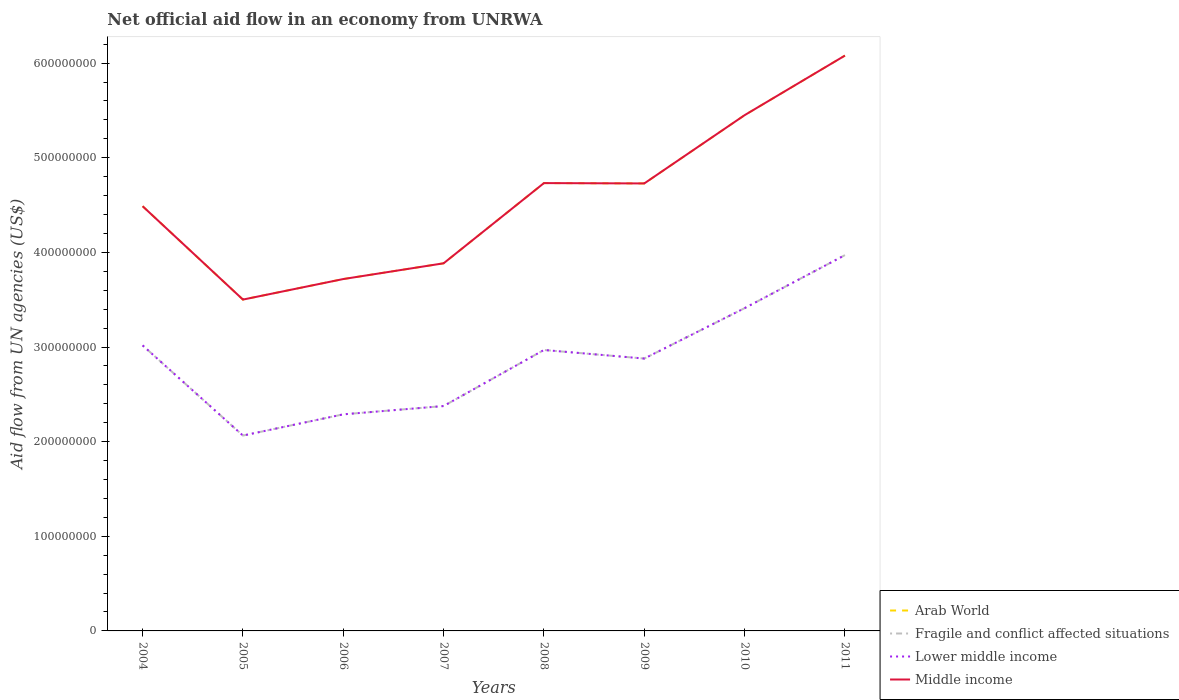How many different coloured lines are there?
Give a very brief answer. 4. Across all years, what is the maximum net official aid flow in Fragile and conflict affected situations?
Make the answer very short. 2.06e+08. In which year was the net official aid flow in Lower middle income maximum?
Your answer should be very brief. 2005. What is the total net official aid flow in Fragile and conflict affected situations in the graph?
Keep it short and to the point. -1.09e+08. What is the difference between the highest and the second highest net official aid flow in Fragile and conflict affected situations?
Provide a succinct answer. 1.91e+08. Is the net official aid flow in Fragile and conflict affected situations strictly greater than the net official aid flow in Arab World over the years?
Keep it short and to the point. Yes. How many years are there in the graph?
Make the answer very short. 8. Are the values on the major ticks of Y-axis written in scientific E-notation?
Your response must be concise. No. Does the graph contain any zero values?
Offer a terse response. No. Does the graph contain grids?
Provide a succinct answer. No. How are the legend labels stacked?
Give a very brief answer. Vertical. What is the title of the graph?
Give a very brief answer. Net official aid flow in an economy from UNRWA. What is the label or title of the Y-axis?
Give a very brief answer. Aid flow from UN agencies (US$). What is the Aid flow from UN agencies (US$) in Arab World in 2004?
Offer a terse response. 4.49e+08. What is the Aid flow from UN agencies (US$) of Fragile and conflict affected situations in 2004?
Offer a terse response. 3.02e+08. What is the Aid flow from UN agencies (US$) of Lower middle income in 2004?
Offer a terse response. 3.02e+08. What is the Aid flow from UN agencies (US$) in Middle income in 2004?
Ensure brevity in your answer.  4.49e+08. What is the Aid flow from UN agencies (US$) of Arab World in 2005?
Your answer should be very brief. 3.50e+08. What is the Aid flow from UN agencies (US$) of Fragile and conflict affected situations in 2005?
Provide a short and direct response. 2.06e+08. What is the Aid flow from UN agencies (US$) of Lower middle income in 2005?
Your response must be concise. 2.06e+08. What is the Aid flow from UN agencies (US$) of Middle income in 2005?
Your answer should be very brief. 3.50e+08. What is the Aid flow from UN agencies (US$) of Arab World in 2006?
Offer a very short reply. 3.72e+08. What is the Aid flow from UN agencies (US$) of Fragile and conflict affected situations in 2006?
Offer a very short reply. 2.29e+08. What is the Aid flow from UN agencies (US$) in Lower middle income in 2006?
Provide a short and direct response. 2.29e+08. What is the Aid flow from UN agencies (US$) of Middle income in 2006?
Your answer should be compact. 3.72e+08. What is the Aid flow from UN agencies (US$) of Arab World in 2007?
Keep it short and to the point. 3.88e+08. What is the Aid flow from UN agencies (US$) in Fragile and conflict affected situations in 2007?
Ensure brevity in your answer.  2.38e+08. What is the Aid flow from UN agencies (US$) of Lower middle income in 2007?
Your answer should be very brief. 2.38e+08. What is the Aid flow from UN agencies (US$) of Middle income in 2007?
Your answer should be very brief. 3.88e+08. What is the Aid flow from UN agencies (US$) of Arab World in 2008?
Your answer should be very brief. 4.73e+08. What is the Aid flow from UN agencies (US$) of Fragile and conflict affected situations in 2008?
Your answer should be compact. 2.97e+08. What is the Aid flow from UN agencies (US$) in Lower middle income in 2008?
Provide a short and direct response. 2.97e+08. What is the Aid flow from UN agencies (US$) in Middle income in 2008?
Your answer should be compact. 4.73e+08. What is the Aid flow from UN agencies (US$) in Arab World in 2009?
Your response must be concise. 4.73e+08. What is the Aid flow from UN agencies (US$) of Fragile and conflict affected situations in 2009?
Give a very brief answer. 2.88e+08. What is the Aid flow from UN agencies (US$) in Lower middle income in 2009?
Ensure brevity in your answer.  2.88e+08. What is the Aid flow from UN agencies (US$) in Middle income in 2009?
Your answer should be compact. 4.73e+08. What is the Aid flow from UN agencies (US$) in Arab World in 2010?
Provide a succinct answer. 5.45e+08. What is the Aid flow from UN agencies (US$) in Fragile and conflict affected situations in 2010?
Keep it short and to the point. 3.41e+08. What is the Aid flow from UN agencies (US$) in Lower middle income in 2010?
Make the answer very short. 3.41e+08. What is the Aid flow from UN agencies (US$) in Middle income in 2010?
Ensure brevity in your answer.  5.45e+08. What is the Aid flow from UN agencies (US$) of Arab World in 2011?
Provide a succinct answer. 6.08e+08. What is the Aid flow from UN agencies (US$) in Fragile and conflict affected situations in 2011?
Offer a terse response. 3.97e+08. What is the Aid flow from UN agencies (US$) in Lower middle income in 2011?
Ensure brevity in your answer.  3.97e+08. What is the Aid flow from UN agencies (US$) in Middle income in 2011?
Provide a short and direct response. 6.08e+08. Across all years, what is the maximum Aid flow from UN agencies (US$) of Arab World?
Keep it short and to the point. 6.08e+08. Across all years, what is the maximum Aid flow from UN agencies (US$) of Fragile and conflict affected situations?
Your answer should be very brief. 3.97e+08. Across all years, what is the maximum Aid flow from UN agencies (US$) of Lower middle income?
Give a very brief answer. 3.97e+08. Across all years, what is the maximum Aid flow from UN agencies (US$) of Middle income?
Your answer should be compact. 6.08e+08. Across all years, what is the minimum Aid flow from UN agencies (US$) of Arab World?
Provide a short and direct response. 3.50e+08. Across all years, what is the minimum Aid flow from UN agencies (US$) in Fragile and conflict affected situations?
Your response must be concise. 2.06e+08. Across all years, what is the minimum Aid flow from UN agencies (US$) in Lower middle income?
Your answer should be very brief. 2.06e+08. Across all years, what is the minimum Aid flow from UN agencies (US$) of Middle income?
Your response must be concise. 3.50e+08. What is the total Aid flow from UN agencies (US$) in Arab World in the graph?
Provide a succinct answer. 3.66e+09. What is the total Aid flow from UN agencies (US$) of Fragile and conflict affected situations in the graph?
Your answer should be compact. 2.30e+09. What is the total Aid flow from UN agencies (US$) in Lower middle income in the graph?
Ensure brevity in your answer.  2.30e+09. What is the total Aid flow from UN agencies (US$) in Middle income in the graph?
Keep it short and to the point. 3.66e+09. What is the difference between the Aid flow from UN agencies (US$) of Arab World in 2004 and that in 2005?
Make the answer very short. 9.87e+07. What is the difference between the Aid flow from UN agencies (US$) in Fragile and conflict affected situations in 2004 and that in 2005?
Keep it short and to the point. 9.53e+07. What is the difference between the Aid flow from UN agencies (US$) of Lower middle income in 2004 and that in 2005?
Your answer should be very brief. 9.53e+07. What is the difference between the Aid flow from UN agencies (US$) of Middle income in 2004 and that in 2005?
Keep it short and to the point. 9.87e+07. What is the difference between the Aid flow from UN agencies (US$) in Arab World in 2004 and that in 2006?
Offer a terse response. 7.70e+07. What is the difference between the Aid flow from UN agencies (US$) of Fragile and conflict affected situations in 2004 and that in 2006?
Provide a short and direct response. 7.29e+07. What is the difference between the Aid flow from UN agencies (US$) of Lower middle income in 2004 and that in 2006?
Your answer should be compact. 7.29e+07. What is the difference between the Aid flow from UN agencies (US$) in Middle income in 2004 and that in 2006?
Ensure brevity in your answer.  7.70e+07. What is the difference between the Aid flow from UN agencies (US$) in Arab World in 2004 and that in 2007?
Keep it short and to the point. 6.03e+07. What is the difference between the Aid flow from UN agencies (US$) in Fragile and conflict affected situations in 2004 and that in 2007?
Provide a short and direct response. 6.41e+07. What is the difference between the Aid flow from UN agencies (US$) in Lower middle income in 2004 and that in 2007?
Offer a very short reply. 6.41e+07. What is the difference between the Aid flow from UN agencies (US$) of Middle income in 2004 and that in 2007?
Your answer should be very brief. 6.03e+07. What is the difference between the Aid flow from UN agencies (US$) of Arab World in 2004 and that in 2008?
Give a very brief answer. -2.44e+07. What is the difference between the Aid flow from UN agencies (US$) of Fragile and conflict affected situations in 2004 and that in 2008?
Provide a succinct answer. 4.86e+06. What is the difference between the Aid flow from UN agencies (US$) of Lower middle income in 2004 and that in 2008?
Offer a terse response. 4.86e+06. What is the difference between the Aid flow from UN agencies (US$) of Middle income in 2004 and that in 2008?
Provide a short and direct response. -2.44e+07. What is the difference between the Aid flow from UN agencies (US$) in Arab World in 2004 and that in 2009?
Make the answer very short. -2.40e+07. What is the difference between the Aid flow from UN agencies (US$) of Fragile and conflict affected situations in 2004 and that in 2009?
Offer a terse response. 1.39e+07. What is the difference between the Aid flow from UN agencies (US$) in Lower middle income in 2004 and that in 2009?
Your response must be concise. 1.39e+07. What is the difference between the Aid flow from UN agencies (US$) of Middle income in 2004 and that in 2009?
Ensure brevity in your answer.  -2.40e+07. What is the difference between the Aid flow from UN agencies (US$) of Arab World in 2004 and that in 2010?
Offer a very short reply. -9.62e+07. What is the difference between the Aid flow from UN agencies (US$) in Fragile and conflict affected situations in 2004 and that in 2010?
Keep it short and to the point. -3.94e+07. What is the difference between the Aid flow from UN agencies (US$) in Lower middle income in 2004 and that in 2010?
Your answer should be compact. -3.94e+07. What is the difference between the Aid flow from UN agencies (US$) of Middle income in 2004 and that in 2010?
Make the answer very short. -9.62e+07. What is the difference between the Aid flow from UN agencies (US$) in Arab World in 2004 and that in 2011?
Keep it short and to the point. -1.59e+08. What is the difference between the Aid flow from UN agencies (US$) of Fragile and conflict affected situations in 2004 and that in 2011?
Keep it short and to the point. -9.54e+07. What is the difference between the Aid flow from UN agencies (US$) in Lower middle income in 2004 and that in 2011?
Offer a terse response. -9.54e+07. What is the difference between the Aid flow from UN agencies (US$) in Middle income in 2004 and that in 2011?
Ensure brevity in your answer.  -1.59e+08. What is the difference between the Aid flow from UN agencies (US$) of Arab World in 2005 and that in 2006?
Provide a short and direct response. -2.17e+07. What is the difference between the Aid flow from UN agencies (US$) of Fragile and conflict affected situations in 2005 and that in 2006?
Provide a short and direct response. -2.24e+07. What is the difference between the Aid flow from UN agencies (US$) of Lower middle income in 2005 and that in 2006?
Ensure brevity in your answer.  -2.24e+07. What is the difference between the Aid flow from UN agencies (US$) of Middle income in 2005 and that in 2006?
Your answer should be very brief. -2.17e+07. What is the difference between the Aid flow from UN agencies (US$) of Arab World in 2005 and that in 2007?
Ensure brevity in your answer.  -3.83e+07. What is the difference between the Aid flow from UN agencies (US$) in Fragile and conflict affected situations in 2005 and that in 2007?
Your answer should be compact. -3.12e+07. What is the difference between the Aid flow from UN agencies (US$) in Lower middle income in 2005 and that in 2007?
Your answer should be very brief. -3.12e+07. What is the difference between the Aid flow from UN agencies (US$) in Middle income in 2005 and that in 2007?
Your answer should be very brief. -3.83e+07. What is the difference between the Aid flow from UN agencies (US$) in Arab World in 2005 and that in 2008?
Give a very brief answer. -1.23e+08. What is the difference between the Aid flow from UN agencies (US$) in Fragile and conflict affected situations in 2005 and that in 2008?
Your answer should be compact. -9.04e+07. What is the difference between the Aid flow from UN agencies (US$) of Lower middle income in 2005 and that in 2008?
Offer a terse response. -9.04e+07. What is the difference between the Aid flow from UN agencies (US$) of Middle income in 2005 and that in 2008?
Provide a succinct answer. -1.23e+08. What is the difference between the Aid flow from UN agencies (US$) of Arab World in 2005 and that in 2009?
Your answer should be compact. -1.23e+08. What is the difference between the Aid flow from UN agencies (US$) of Fragile and conflict affected situations in 2005 and that in 2009?
Give a very brief answer. -8.14e+07. What is the difference between the Aid flow from UN agencies (US$) of Lower middle income in 2005 and that in 2009?
Offer a very short reply. -8.14e+07. What is the difference between the Aid flow from UN agencies (US$) of Middle income in 2005 and that in 2009?
Offer a very short reply. -1.23e+08. What is the difference between the Aid flow from UN agencies (US$) of Arab World in 2005 and that in 2010?
Keep it short and to the point. -1.95e+08. What is the difference between the Aid flow from UN agencies (US$) of Fragile and conflict affected situations in 2005 and that in 2010?
Provide a succinct answer. -1.35e+08. What is the difference between the Aid flow from UN agencies (US$) in Lower middle income in 2005 and that in 2010?
Your response must be concise. -1.35e+08. What is the difference between the Aid flow from UN agencies (US$) of Middle income in 2005 and that in 2010?
Your response must be concise. -1.95e+08. What is the difference between the Aid flow from UN agencies (US$) of Arab World in 2005 and that in 2011?
Offer a terse response. -2.58e+08. What is the difference between the Aid flow from UN agencies (US$) in Fragile and conflict affected situations in 2005 and that in 2011?
Offer a very short reply. -1.91e+08. What is the difference between the Aid flow from UN agencies (US$) in Lower middle income in 2005 and that in 2011?
Ensure brevity in your answer.  -1.91e+08. What is the difference between the Aid flow from UN agencies (US$) of Middle income in 2005 and that in 2011?
Your answer should be compact. -2.58e+08. What is the difference between the Aid flow from UN agencies (US$) in Arab World in 2006 and that in 2007?
Offer a terse response. -1.66e+07. What is the difference between the Aid flow from UN agencies (US$) in Fragile and conflict affected situations in 2006 and that in 2007?
Offer a terse response. -8.77e+06. What is the difference between the Aid flow from UN agencies (US$) in Lower middle income in 2006 and that in 2007?
Offer a terse response. -8.77e+06. What is the difference between the Aid flow from UN agencies (US$) in Middle income in 2006 and that in 2007?
Offer a terse response. -1.66e+07. What is the difference between the Aid flow from UN agencies (US$) of Arab World in 2006 and that in 2008?
Provide a succinct answer. -1.01e+08. What is the difference between the Aid flow from UN agencies (US$) in Fragile and conflict affected situations in 2006 and that in 2008?
Your response must be concise. -6.80e+07. What is the difference between the Aid flow from UN agencies (US$) of Lower middle income in 2006 and that in 2008?
Make the answer very short. -6.80e+07. What is the difference between the Aid flow from UN agencies (US$) in Middle income in 2006 and that in 2008?
Make the answer very short. -1.01e+08. What is the difference between the Aid flow from UN agencies (US$) in Arab World in 2006 and that in 2009?
Give a very brief answer. -1.01e+08. What is the difference between the Aid flow from UN agencies (US$) in Fragile and conflict affected situations in 2006 and that in 2009?
Provide a succinct answer. -5.90e+07. What is the difference between the Aid flow from UN agencies (US$) of Lower middle income in 2006 and that in 2009?
Your answer should be very brief. -5.90e+07. What is the difference between the Aid flow from UN agencies (US$) of Middle income in 2006 and that in 2009?
Give a very brief answer. -1.01e+08. What is the difference between the Aid flow from UN agencies (US$) in Arab World in 2006 and that in 2010?
Your answer should be very brief. -1.73e+08. What is the difference between the Aid flow from UN agencies (US$) of Fragile and conflict affected situations in 2006 and that in 2010?
Your answer should be very brief. -1.12e+08. What is the difference between the Aid flow from UN agencies (US$) in Lower middle income in 2006 and that in 2010?
Provide a succinct answer. -1.12e+08. What is the difference between the Aid flow from UN agencies (US$) of Middle income in 2006 and that in 2010?
Keep it short and to the point. -1.73e+08. What is the difference between the Aid flow from UN agencies (US$) of Arab World in 2006 and that in 2011?
Offer a very short reply. -2.36e+08. What is the difference between the Aid flow from UN agencies (US$) of Fragile and conflict affected situations in 2006 and that in 2011?
Keep it short and to the point. -1.68e+08. What is the difference between the Aid flow from UN agencies (US$) of Lower middle income in 2006 and that in 2011?
Your answer should be compact. -1.68e+08. What is the difference between the Aid flow from UN agencies (US$) of Middle income in 2006 and that in 2011?
Offer a very short reply. -2.36e+08. What is the difference between the Aid flow from UN agencies (US$) in Arab World in 2007 and that in 2008?
Provide a succinct answer. -8.48e+07. What is the difference between the Aid flow from UN agencies (US$) of Fragile and conflict affected situations in 2007 and that in 2008?
Provide a short and direct response. -5.92e+07. What is the difference between the Aid flow from UN agencies (US$) of Lower middle income in 2007 and that in 2008?
Provide a succinct answer. -5.92e+07. What is the difference between the Aid flow from UN agencies (US$) of Middle income in 2007 and that in 2008?
Give a very brief answer. -8.48e+07. What is the difference between the Aid flow from UN agencies (US$) of Arab World in 2007 and that in 2009?
Your response must be concise. -8.44e+07. What is the difference between the Aid flow from UN agencies (US$) of Fragile and conflict affected situations in 2007 and that in 2009?
Keep it short and to the point. -5.02e+07. What is the difference between the Aid flow from UN agencies (US$) of Lower middle income in 2007 and that in 2009?
Your answer should be compact. -5.02e+07. What is the difference between the Aid flow from UN agencies (US$) in Middle income in 2007 and that in 2009?
Your answer should be compact. -8.44e+07. What is the difference between the Aid flow from UN agencies (US$) of Arab World in 2007 and that in 2010?
Your response must be concise. -1.57e+08. What is the difference between the Aid flow from UN agencies (US$) of Fragile and conflict affected situations in 2007 and that in 2010?
Offer a very short reply. -1.03e+08. What is the difference between the Aid flow from UN agencies (US$) of Lower middle income in 2007 and that in 2010?
Give a very brief answer. -1.03e+08. What is the difference between the Aid flow from UN agencies (US$) in Middle income in 2007 and that in 2010?
Your answer should be compact. -1.57e+08. What is the difference between the Aid flow from UN agencies (US$) of Arab World in 2007 and that in 2011?
Your response must be concise. -2.20e+08. What is the difference between the Aid flow from UN agencies (US$) in Fragile and conflict affected situations in 2007 and that in 2011?
Offer a very short reply. -1.59e+08. What is the difference between the Aid flow from UN agencies (US$) in Lower middle income in 2007 and that in 2011?
Keep it short and to the point. -1.59e+08. What is the difference between the Aid flow from UN agencies (US$) in Middle income in 2007 and that in 2011?
Ensure brevity in your answer.  -2.20e+08. What is the difference between the Aid flow from UN agencies (US$) of Fragile and conflict affected situations in 2008 and that in 2009?
Provide a short and direct response. 9.05e+06. What is the difference between the Aid flow from UN agencies (US$) in Lower middle income in 2008 and that in 2009?
Provide a succinct answer. 9.05e+06. What is the difference between the Aid flow from UN agencies (US$) in Middle income in 2008 and that in 2009?
Give a very brief answer. 3.60e+05. What is the difference between the Aid flow from UN agencies (US$) of Arab World in 2008 and that in 2010?
Your answer should be very brief. -7.18e+07. What is the difference between the Aid flow from UN agencies (US$) in Fragile and conflict affected situations in 2008 and that in 2010?
Make the answer very short. -4.42e+07. What is the difference between the Aid flow from UN agencies (US$) of Lower middle income in 2008 and that in 2010?
Ensure brevity in your answer.  -4.42e+07. What is the difference between the Aid flow from UN agencies (US$) of Middle income in 2008 and that in 2010?
Make the answer very short. -7.18e+07. What is the difference between the Aid flow from UN agencies (US$) in Arab World in 2008 and that in 2011?
Keep it short and to the point. -1.35e+08. What is the difference between the Aid flow from UN agencies (US$) in Fragile and conflict affected situations in 2008 and that in 2011?
Provide a succinct answer. -1.00e+08. What is the difference between the Aid flow from UN agencies (US$) of Lower middle income in 2008 and that in 2011?
Your answer should be very brief. -1.00e+08. What is the difference between the Aid flow from UN agencies (US$) of Middle income in 2008 and that in 2011?
Provide a short and direct response. -1.35e+08. What is the difference between the Aid flow from UN agencies (US$) in Arab World in 2009 and that in 2010?
Offer a very short reply. -7.21e+07. What is the difference between the Aid flow from UN agencies (US$) of Fragile and conflict affected situations in 2009 and that in 2010?
Your response must be concise. -5.33e+07. What is the difference between the Aid flow from UN agencies (US$) in Lower middle income in 2009 and that in 2010?
Your response must be concise. -5.33e+07. What is the difference between the Aid flow from UN agencies (US$) of Middle income in 2009 and that in 2010?
Ensure brevity in your answer.  -7.21e+07. What is the difference between the Aid flow from UN agencies (US$) of Arab World in 2009 and that in 2011?
Your answer should be very brief. -1.35e+08. What is the difference between the Aid flow from UN agencies (US$) in Fragile and conflict affected situations in 2009 and that in 2011?
Your answer should be very brief. -1.09e+08. What is the difference between the Aid flow from UN agencies (US$) of Lower middle income in 2009 and that in 2011?
Make the answer very short. -1.09e+08. What is the difference between the Aid flow from UN agencies (US$) in Middle income in 2009 and that in 2011?
Offer a very short reply. -1.35e+08. What is the difference between the Aid flow from UN agencies (US$) of Arab World in 2010 and that in 2011?
Your response must be concise. -6.30e+07. What is the difference between the Aid flow from UN agencies (US$) of Fragile and conflict affected situations in 2010 and that in 2011?
Your answer should be compact. -5.60e+07. What is the difference between the Aid flow from UN agencies (US$) of Lower middle income in 2010 and that in 2011?
Your response must be concise. -5.60e+07. What is the difference between the Aid flow from UN agencies (US$) of Middle income in 2010 and that in 2011?
Provide a short and direct response. -6.30e+07. What is the difference between the Aid flow from UN agencies (US$) of Arab World in 2004 and the Aid flow from UN agencies (US$) of Fragile and conflict affected situations in 2005?
Make the answer very short. 2.42e+08. What is the difference between the Aid flow from UN agencies (US$) of Arab World in 2004 and the Aid flow from UN agencies (US$) of Lower middle income in 2005?
Your answer should be compact. 2.42e+08. What is the difference between the Aid flow from UN agencies (US$) in Arab World in 2004 and the Aid flow from UN agencies (US$) in Middle income in 2005?
Your answer should be compact. 9.87e+07. What is the difference between the Aid flow from UN agencies (US$) in Fragile and conflict affected situations in 2004 and the Aid flow from UN agencies (US$) in Lower middle income in 2005?
Your answer should be compact. 9.53e+07. What is the difference between the Aid flow from UN agencies (US$) of Fragile and conflict affected situations in 2004 and the Aid flow from UN agencies (US$) of Middle income in 2005?
Make the answer very short. -4.84e+07. What is the difference between the Aid flow from UN agencies (US$) in Lower middle income in 2004 and the Aid flow from UN agencies (US$) in Middle income in 2005?
Provide a succinct answer. -4.84e+07. What is the difference between the Aid flow from UN agencies (US$) in Arab World in 2004 and the Aid flow from UN agencies (US$) in Fragile and conflict affected situations in 2006?
Provide a succinct answer. 2.20e+08. What is the difference between the Aid flow from UN agencies (US$) in Arab World in 2004 and the Aid flow from UN agencies (US$) in Lower middle income in 2006?
Your response must be concise. 2.20e+08. What is the difference between the Aid flow from UN agencies (US$) of Arab World in 2004 and the Aid flow from UN agencies (US$) of Middle income in 2006?
Keep it short and to the point. 7.70e+07. What is the difference between the Aid flow from UN agencies (US$) of Fragile and conflict affected situations in 2004 and the Aid flow from UN agencies (US$) of Lower middle income in 2006?
Keep it short and to the point. 7.29e+07. What is the difference between the Aid flow from UN agencies (US$) in Fragile and conflict affected situations in 2004 and the Aid flow from UN agencies (US$) in Middle income in 2006?
Provide a short and direct response. -7.01e+07. What is the difference between the Aid flow from UN agencies (US$) in Lower middle income in 2004 and the Aid flow from UN agencies (US$) in Middle income in 2006?
Offer a terse response. -7.01e+07. What is the difference between the Aid flow from UN agencies (US$) in Arab World in 2004 and the Aid flow from UN agencies (US$) in Fragile and conflict affected situations in 2007?
Offer a terse response. 2.11e+08. What is the difference between the Aid flow from UN agencies (US$) in Arab World in 2004 and the Aid flow from UN agencies (US$) in Lower middle income in 2007?
Make the answer very short. 2.11e+08. What is the difference between the Aid flow from UN agencies (US$) of Arab World in 2004 and the Aid flow from UN agencies (US$) of Middle income in 2007?
Your response must be concise. 6.03e+07. What is the difference between the Aid flow from UN agencies (US$) of Fragile and conflict affected situations in 2004 and the Aid flow from UN agencies (US$) of Lower middle income in 2007?
Offer a terse response. 6.41e+07. What is the difference between the Aid flow from UN agencies (US$) of Fragile and conflict affected situations in 2004 and the Aid flow from UN agencies (US$) of Middle income in 2007?
Offer a very short reply. -8.67e+07. What is the difference between the Aid flow from UN agencies (US$) in Lower middle income in 2004 and the Aid flow from UN agencies (US$) in Middle income in 2007?
Your response must be concise. -8.67e+07. What is the difference between the Aid flow from UN agencies (US$) in Arab World in 2004 and the Aid flow from UN agencies (US$) in Fragile and conflict affected situations in 2008?
Your answer should be very brief. 1.52e+08. What is the difference between the Aid flow from UN agencies (US$) in Arab World in 2004 and the Aid flow from UN agencies (US$) in Lower middle income in 2008?
Keep it short and to the point. 1.52e+08. What is the difference between the Aid flow from UN agencies (US$) in Arab World in 2004 and the Aid flow from UN agencies (US$) in Middle income in 2008?
Your response must be concise. -2.44e+07. What is the difference between the Aid flow from UN agencies (US$) of Fragile and conflict affected situations in 2004 and the Aid flow from UN agencies (US$) of Lower middle income in 2008?
Offer a terse response. 4.86e+06. What is the difference between the Aid flow from UN agencies (US$) of Fragile and conflict affected situations in 2004 and the Aid flow from UN agencies (US$) of Middle income in 2008?
Provide a short and direct response. -1.71e+08. What is the difference between the Aid flow from UN agencies (US$) in Lower middle income in 2004 and the Aid flow from UN agencies (US$) in Middle income in 2008?
Offer a very short reply. -1.71e+08. What is the difference between the Aid flow from UN agencies (US$) in Arab World in 2004 and the Aid flow from UN agencies (US$) in Fragile and conflict affected situations in 2009?
Ensure brevity in your answer.  1.61e+08. What is the difference between the Aid flow from UN agencies (US$) in Arab World in 2004 and the Aid flow from UN agencies (US$) in Lower middle income in 2009?
Offer a terse response. 1.61e+08. What is the difference between the Aid flow from UN agencies (US$) in Arab World in 2004 and the Aid flow from UN agencies (US$) in Middle income in 2009?
Make the answer very short. -2.40e+07. What is the difference between the Aid flow from UN agencies (US$) in Fragile and conflict affected situations in 2004 and the Aid flow from UN agencies (US$) in Lower middle income in 2009?
Make the answer very short. 1.39e+07. What is the difference between the Aid flow from UN agencies (US$) of Fragile and conflict affected situations in 2004 and the Aid flow from UN agencies (US$) of Middle income in 2009?
Provide a succinct answer. -1.71e+08. What is the difference between the Aid flow from UN agencies (US$) of Lower middle income in 2004 and the Aid flow from UN agencies (US$) of Middle income in 2009?
Your answer should be compact. -1.71e+08. What is the difference between the Aid flow from UN agencies (US$) in Arab World in 2004 and the Aid flow from UN agencies (US$) in Fragile and conflict affected situations in 2010?
Provide a succinct answer. 1.08e+08. What is the difference between the Aid flow from UN agencies (US$) of Arab World in 2004 and the Aid flow from UN agencies (US$) of Lower middle income in 2010?
Keep it short and to the point. 1.08e+08. What is the difference between the Aid flow from UN agencies (US$) in Arab World in 2004 and the Aid flow from UN agencies (US$) in Middle income in 2010?
Provide a succinct answer. -9.62e+07. What is the difference between the Aid flow from UN agencies (US$) of Fragile and conflict affected situations in 2004 and the Aid flow from UN agencies (US$) of Lower middle income in 2010?
Your answer should be very brief. -3.94e+07. What is the difference between the Aid flow from UN agencies (US$) of Fragile and conflict affected situations in 2004 and the Aid flow from UN agencies (US$) of Middle income in 2010?
Ensure brevity in your answer.  -2.43e+08. What is the difference between the Aid flow from UN agencies (US$) in Lower middle income in 2004 and the Aid flow from UN agencies (US$) in Middle income in 2010?
Make the answer very short. -2.43e+08. What is the difference between the Aid flow from UN agencies (US$) in Arab World in 2004 and the Aid flow from UN agencies (US$) in Fragile and conflict affected situations in 2011?
Make the answer very short. 5.17e+07. What is the difference between the Aid flow from UN agencies (US$) in Arab World in 2004 and the Aid flow from UN agencies (US$) in Lower middle income in 2011?
Make the answer very short. 5.17e+07. What is the difference between the Aid flow from UN agencies (US$) in Arab World in 2004 and the Aid flow from UN agencies (US$) in Middle income in 2011?
Ensure brevity in your answer.  -1.59e+08. What is the difference between the Aid flow from UN agencies (US$) in Fragile and conflict affected situations in 2004 and the Aid flow from UN agencies (US$) in Lower middle income in 2011?
Make the answer very short. -9.54e+07. What is the difference between the Aid flow from UN agencies (US$) of Fragile and conflict affected situations in 2004 and the Aid flow from UN agencies (US$) of Middle income in 2011?
Keep it short and to the point. -3.06e+08. What is the difference between the Aid flow from UN agencies (US$) of Lower middle income in 2004 and the Aid flow from UN agencies (US$) of Middle income in 2011?
Your response must be concise. -3.06e+08. What is the difference between the Aid flow from UN agencies (US$) of Arab World in 2005 and the Aid flow from UN agencies (US$) of Fragile and conflict affected situations in 2006?
Provide a succinct answer. 1.21e+08. What is the difference between the Aid flow from UN agencies (US$) in Arab World in 2005 and the Aid flow from UN agencies (US$) in Lower middle income in 2006?
Provide a short and direct response. 1.21e+08. What is the difference between the Aid flow from UN agencies (US$) of Arab World in 2005 and the Aid flow from UN agencies (US$) of Middle income in 2006?
Provide a succinct answer. -2.17e+07. What is the difference between the Aid flow from UN agencies (US$) in Fragile and conflict affected situations in 2005 and the Aid flow from UN agencies (US$) in Lower middle income in 2006?
Ensure brevity in your answer.  -2.24e+07. What is the difference between the Aid flow from UN agencies (US$) in Fragile and conflict affected situations in 2005 and the Aid flow from UN agencies (US$) in Middle income in 2006?
Ensure brevity in your answer.  -1.65e+08. What is the difference between the Aid flow from UN agencies (US$) in Lower middle income in 2005 and the Aid flow from UN agencies (US$) in Middle income in 2006?
Ensure brevity in your answer.  -1.65e+08. What is the difference between the Aid flow from UN agencies (US$) of Arab World in 2005 and the Aid flow from UN agencies (US$) of Fragile and conflict affected situations in 2007?
Offer a terse response. 1.12e+08. What is the difference between the Aid flow from UN agencies (US$) of Arab World in 2005 and the Aid flow from UN agencies (US$) of Lower middle income in 2007?
Offer a very short reply. 1.12e+08. What is the difference between the Aid flow from UN agencies (US$) in Arab World in 2005 and the Aid flow from UN agencies (US$) in Middle income in 2007?
Offer a terse response. -3.83e+07. What is the difference between the Aid flow from UN agencies (US$) in Fragile and conflict affected situations in 2005 and the Aid flow from UN agencies (US$) in Lower middle income in 2007?
Your answer should be compact. -3.12e+07. What is the difference between the Aid flow from UN agencies (US$) in Fragile and conflict affected situations in 2005 and the Aid flow from UN agencies (US$) in Middle income in 2007?
Keep it short and to the point. -1.82e+08. What is the difference between the Aid flow from UN agencies (US$) in Lower middle income in 2005 and the Aid flow from UN agencies (US$) in Middle income in 2007?
Your answer should be very brief. -1.82e+08. What is the difference between the Aid flow from UN agencies (US$) in Arab World in 2005 and the Aid flow from UN agencies (US$) in Fragile and conflict affected situations in 2008?
Give a very brief answer. 5.33e+07. What is the difference between the Aid flow from UN agencies (US$) in Arab World in 2005 and the Aid flow from UN agencies (US$) in Lower middle income in 2008?
Make the answer very short. 5.33e+07. What is the difference between the Aid flow from UN agencies (US$) in Arab World in 2005 and the Aid flow from UN agencies (US$) in Middle income in 2008?
Keep it short and to the point. -1.23e+08. What is the difference between the Aid flow from UN agencies (US$) in Fragile and conflict affected situations in 2005 and the Aid flow from UN agencies (US$) in Lower middle income in 2008?
Your response must be concise. -9.04e+07. What is the difference between the Aid flow from UN agencies (US$) of Fragile and conflict affected situations in 2005 and the Aid flow from UN agencies (US$) of Middle income in 2008?
Your answer should be very brief. -2.67e+08. What is the difference between the Aid flow from UN agencies (US$) of Lower middle income in 2005 and the Aid flow from UN agencies (US$) of Middle income in 2008?
Provide a short and direct response. -2.67e+08. What is the difference between the Aid flow from UN agencies (US$) of Arab World in 2005 and the Aid flow from UN agencies (US$) of Fragile and conflict affected situations in 2009?
Your answer should be compact. 6.23e+07. What is the difference between the Aid flow from UN agencies (US$) in Arab World in 2005 and the Aid flow from UN agencies (US$) in Lower middle income in 2009?
Your answer should be very brief. 6.23e+07. What is the difference between the Aid flow from UN agencies (US$) of Arab World in 2005 and the Aid flow from UN agencies (US$) of Middle income in 2009?
Offer a terse response. -1.23e+08. What is the difference between the Aid flow from UN agencies (US$) of Fragile and conflict affected situations in 2005 and the Aid flow from UN agencies (US$) of Lower middle income in 2009?
Ensure brevity in your answer.  -8.14e+07. What is the difference between the Aid flow from UN agencies (US$) of Fragile and conflict affected situations in 2005 and the Aid flow from UN agencies (US$) of Middle income in 2009?
Your answer should be compact. -2.66e+08. What is the difference between the Aid flow from UN agencies (US$) of Lower middle income in 2005 and the Aid flow from UN agencies (US$) of Middle income in 2009?
Offer a terse response. -2.66e+08. What is the difference between the Aid flow from UN agencies (US$) in Arab World in 2005 and the Aid flow from UN agencies (US$) in Fragile and conflict affected situations in 2010?
Your response must be concise. 9.05e+06. What is the difference between the Aid flow from UN agencies (US$) in Arab World in 2005 and the Aid flow from UN agencies (US$) in Lower middle income in 2010?
Your answer should be very brief. 9.05e+06. What is the difference between the Aid flow from UN agencies (US$) in Arab World in 2005 and the Aid flow from UN agencies (US$) in Middle income in 2010?
Provide a succinct answer. -1.95e+08. What is the difference between the Aid flow from UN agencies (US$) of Fragile and conflict affected situations in 2005 and the Aid flow from UN agencies (US$) of Lower middle income in 2010?
Offer a very short reply. -1.35e+08. What is the difference between the Aid flow from UN agencies (US$) in Fragile and conflict affected situations in 2005 and the Aid flow from UN agencies (US$) in Middle income in 2010?
Provide a short and direct response. -3.39e+08. What is the difference between the Aid flow from UN agencies (US$) in Lower middle income in 2005 and the Aid flow from UN agencies (US$) in Middle income in 2010?
Give a very brief answer. -3.39e+08. What is the difference between the Aid flow from UN agencies (US$) in Arab World in 2005 and the Aid flow from UN agencies (US$) in Fragile and conflict affected situations in 2011?
Ensure brevity in your answer.  -4.70e+07. What is the difference between the Aid flow from UN agencies (US$) of Arab World in 2005 and the Aid flow from UN agencies (US$) of Lower middle income in 2011?
Offer a very short reply. -4.70e+07. What is the difference between the Aid flow from UN agencies (US$) of Arab World in 2005 and the Aid flow from UN agencies (US$) of Middle income in 2011?
Offer a very short reply. -2.58e+08. What is the difference between the Aid flow from UN agencies (US$) of Fragile and conflict affected situations in 2005 and the Aid flow from UN agencies (US$) of Lower middle income in 2011?
Ensure brevity in your answer.  -1.91e+08. What is the difference between the Aid flow from UN agencies (US$) in Fragile and conflict affected situations in 2005 and the Aid flow from UN agencies (US$) in Middle income in 2011?
Give a very brief answer. -4.02e+08. What is the difference between the Aid flow from UN agencies (US$) in Lower middle income in 2005 and the Aid flow from UN agencies (US$) in Middle income in 2011?
Ensure brevity in your answer.  -4.02e+08. What is the difference between the Aid flow from UN agencies (US$) in Arab World in 2006 and the Aid flow from UN agencies (US$) in Fragile and conflict affected situations in 2007?
Provide a succinct answer. 1.34e+08. What is the difference between the Aid flow from UN agencies (US$) of Arab World in 2006 and the Aid flow from UN agencies (US$) of Lower middle income in 2007?
Keep it short and to the point. 1.34e+08. What is the difference between the Aid flow from UN agencies (US$) of Arab World in 2006 and the Aid flow from UN agencies (US$) of Middle income in 2007?
Offer a terse response. -1.66e+07. What is the difference between the Aid flow from UN agencies (US$) of Fragile and conflict affected situations in 2006 and the Aid flow from UN agencies (US$) of Lower middle income in 2007?
Your response must be concise. -8.77e+06. What is the difference between the Aid flow from UN agencies (US$) in Fragile and conflict affected situations in 2006 and the Aid flow from UN agencies (US$) in Middle income in 2007?
Provide a succinct answer. -1.60e+08. What is the difference between the Aid flow from UN agencies (US$) in Lower middle income in 2006 and the Aid flow from UN agencies (US$) in Middle income in 2007?
Make the answer very short. -1.60e+08. What is the difference between the Aid flow from UN agencies (US$) of Arab World in 2006 and the Aid flow from UN agencies (US$) of Fragile and conflict affected situations in 2008?
Provide a succinct answer. 7.50e+07. What is the difference between the Aid flow from UN agencies (US$) in Arab World in 2006 and the Aid flow from UN agencies (US$) in Lower middle income in 2008?
Offer a terse response. 7.50e+07. What is the difference between the Aid flow from UN agencies (US$) of Arab World in 2006 and the Aid flow from UN agencies (US$) of Middle income in 2008?
Your response must be concise. -1.01e+08. What is the difference between the Aid flow from UN agencies (US$) in Fragile and conflict affected situations in 2006 and the Aid flow from UN agencies (US$) in Lower middle income in 2008?
Offer a terse response. -6.80e+07. What is the difference between the Aid flow from UN agencies (US$) of Fragile and conflict affected situations in 2006 and the Aid flow from UN agencies (US$) of Middle income in 2008?
Provide a succinct answer. -2.44e+08. What is the difference between the Aid flow from UN agencies (US$) in Lower middle income in 2006 and the Aid flow from UN agencies (US$) in Middle income in 2008?
Provide a short and direct response. -2.44e+08. What is the difference between the Aid flow from UN agencies (US$) of Arab World in 2006 and the Aid flow from UN agencies (US$) of Fragile and conflict affected situations in 2009?
Offer a terse response. 8.40e+07. What is the difference between the Aid flow from UN agencies (US$) of Arab World in 2006 and the Aid flow from UN agencies (US$) of Lower middle income in 2009?
Make the answer very short. 8.40e+07. What is the difference between the Aid flow from UN agencies (US$) in Arab World in 2006 and the Aid flow from UN agencies (US$) in Middle income in 2009?
Provide a succinct answer. -1.01e+08. What is the difference between the Aid flow from UN agencies (US$) of Fragile and conflict affected situations in 2006 and the Aid flow from UN agencies (US$) of Lower middle income in 2009?
Provide a succinct answer. -5.90e+07. What is the difference between the Aid flow from UN agencies (US$) in Fragile and conflict affected situations in 2006 and the Aid flow from UN agencies (US$) in Middle income in 2009?
Make the answer very short. -2.44e+08. What is the difference between the Aid flow from UN agencies (US$) in Lower middle income in 2006 and the Aid flow from UN agencies (US$) in Middle income in 2009?
Provide a short and direct response. -2.44e+08. What is the difference between the Aid flow from UN agencies (US$) in Arab World in 2006 and the Aid flow from UN agencies (US$) in Fragile and conflict affected situations in 2010?
Offer a terse response. 3.08e+07. What is the difference between the Aid flow from UN agencies (US$) in Arab World in 2006 and the Aid flow from UN agencies (US$) in Lower middle income in 2010?
Keep it short and to the point. 3.08e+07. What is the difference between the Aid flow from UN agencies (US$) of Arab World in 2006 and the Aid flow from UN agencies (US$) of Middle income in 2010?
Your response must be concise. -1.73e+08. What is the difference between the Aid flow from UN agencies (US$) of Fragile and conflict affected situations in 2006 and the Aid flow from UN agencies (US$) of Lower middle income in 2010?
Ensure brevity in your answer.  -1.12e+08. What is the difference between the Aid flow from UN agencies (US$) of Fragile and conflict affected situations in 2006 and the Aid flow from UN agencies (US$) of Middle income in 2010?
Give a very brief answer. -3.16e+08. What is the difference between the Aid flow from UN agencies (US$) of Lower middle income in 2006 and the Aid flow from UN agencies (US$) of Middle income in 2010?
Your answer should be very brief. -3.16e+08. What is the difference between the Aid flow from UN agencies (US$) in Arab World in 2006 and the Aid flow from UN agencies (US$) in Fragile and conflict affected situations in 2011?
Your response must be concise. -2.53e+07. What is the difference between the Aid flow from UN agencies (US$) in Arab World in 2006 and the Aid flow from UN agencies (US$) in Lower middle income in 2011?
Give a very brief answer. -2.53e+07. What is the difference between the Aid flow from UN agencies (US$) of Arab World in 2006 and the Aid flow from UN agencies (US$) of Middle income in 2011?
Offer a very short reply. -2.36e+08. What is the difference between the Aid flow from UN agencies (US$) in Fragile and conflict affected situations in 2006 and the Aid flow from UN agencies (US$) in Lower middle income in 2011?
Your response must be concise. -1.68e+08. What is the difference between the Aid flow from UN agencies (US$) of Fragile and conflict affected situations in 2006 and the Aid flow from UN agencies (US$) of Middle income in 2011?
Offer a very short reply. -3.79e+08. What is the difference between the Aid flow from UN agencies (US$) of Lower middle income in 2006 and the Aid flow from UN agencies (US$) of Middle income in 2011?
Give a very brief answer. -3.79e+08. What is the difference between the Aid flow from UN agencies (US$) in Arab World in 2007 and the Aid flow from UN agencies (US$) in Fragile and conflict affected situations in 2008?
Offer a terse response. 9.16e+07. What is the difference between the Aid flow from UN agencies (US$) in Arab World in 2007 and the Aid flow from UN agencies (US$) in Lower middle income in 2008?
Give a very brief answer. 9.16e+07. What is the difference between the Aid flow from UN agencies (US$) in Arab World in 2007 and the Aid flow from UN agencies (US$) in Middle income in 2008?
Your answer should be compact. -8.48e+07. What is the difference between the Aid flow from UN agencies (US$) of Fragile and conflict affected situations in 2007 and the Aid flow from UN agencies (US$) of Lower middle income in 2008?
Keep it short and to the point. -5.92e+07. What is the difference between the Aid flow from UN agencies (US$) of Fragile and conflict affected situations in 2007 and the Aid flow from UN agencies (US$) of Middle income in 2008?
Offer a very short reply. -2.36e+08. What is the difference between the Aid flow from UN agencies (US$) in Lower middle income in 2007 and the Aid flow from UN agencies (US$) in Middle income in 2008?
Provide a succinct answer. -2.36e+08. What is the difference between the Aid flow from UN agencies (US$) of Arab World in 2007 and the Aid flow from UN agencies (US$) of Fragile and conflict affected situations in 2009?
Ensure brevity in your answer.  1.01e+08. What is the difference between the Aid flow from UN agencies (US$) of Arab World in 2007 and the Aid flow from UN agencies (US$) of Lower middle income in 2009?
Ensure brevity in your answer.  1.01e+08. What is the difference between the Aid flow from UN agencies (US$) in Arab World in 2007 and the Aid flow from UN agencies (US$) in Middle income in 2009?
Your answer should be compact. -8.44e+07. What is the difference between the Aid flow from UN agencies (US$) of Fragile and conflict affected situations in 2007 and the Aid flow from UN agencies (US$) of Lower middle income in 2009?
Offer a very short reply. -5.02e+07. What is the difference between the Aid flow from UN agencies (US$) in Fragile and conflict affected situations in 2007 and the Aid flow from UN agencies (US$) in Middle income in 2009?
Keep it short and to the point. -2.35e+08. What is the difference between the Aid flow from UN agencies (US$) of Lower middle income in 2007 and the Aid flow from UN agencies (US$) of Middle income in 2009?
Give a very brief answer. -2.35e+08. What is the difference between the Aid flow from UN agencies (US$) of Arab World in 2007 and the Aid flow from UN agencies (US$) of Fragile and conflict affected situations in 2010?
Your response must be concise. 4.74e+07. What is the difference between the Aid flow from UN agencies (US$) of Arab World in 2007 and the Aid flow from UN agencies (US$) of Lower middle income in 2010?
Your answer should be compact. 4.74e+07. What is the difference between the Aid flow from UN agencies (US$) in Arab World in 2007 and the Aid flow from UN agencies (US$) in Middle income in 2010?
Ensure brevity in your answer.  -1.57e+08. What is the difference between the Aid flow from UN agencies (US$) of Fragile and conflict affected situations in 2007 and the Aid flow from UN agencies (US$) of Lower middle income in 2010?
Provide a succinct answer. -1.03e+08. What is the difference between the Aid flow from UN agencies (US$) in Fragile and conflict affected situations in 2007 and the Aid flow from UN agencies (US$) in Middle income in 2010?
Provide a succinct answer. -3.07e+08. What is the difference between the Aid flow from UN agencies (US$) of Lower middle income in 2007 and the Aid flow from UN agencies (US$) of Middle income in 2010?
Provide a short and direct response. -3.07e+08. What is the difference between the Aid flow from UN agencies (US$) in Arab World in 2007 and the Aid flow from UN agencies (US$) in Fragile and conflict affected situations in 2011?
Provide a short and direct response. -8.65e+06. What is the difference between the Aid flow from UN agencies (US$) of Arab World in 2007 and the Aid flow from UN agencies (US$) of Lower middle income in 2011?
Provide a short and direct response. -8.65e+06. What is the difference between the Aid flow from UN agencies (US$) of Arab World in 2007 and the Aid flow from UN agencies (US$) of Middle income in 2011?
Your response must be concise. -2.20e+08. What is the difference between the Aid flow from UN agencies (US$) of Fragile and conflict affected situations in 2007 and the Aid flow from UN agencies (US$) of Lower middle income in 2011?
Make the answer very short. -1.59e+08. What is the difference between the Aid flow from UN agencies (US$) of Fragile and conflict affected situations in 2007 and the Aid flow from UN agencies (US$) of Middle income in 2011?
Your answer should be very brief. -3.70e+08. What is the difference between the Aid flow from UN agencies (US$) of Lower middle income in 2007 and the Aid flow from UN agencies (US$) of Middle income in 2011?
Your response must be concise. -3.70e+08. What is the difference between the Aid flow from UN agencies (US$) in Arab World in 2008 and the Aid flow from UN agencies (US$) in Fragile and conflict affected situations in 2009?
Offer a very short reply. 1.85e+08. What is the difference between the Aid flow from UN agencies (US$) in Arab World in 2008 and the Aid flow from UN agencies (US$) in Lower middle income in 2009?
Your answer should be compact. 1.85e+08. What is the difference between the Aid flow from UN agencies (US$) of Fragile and conflict affected situations in 2008 and the Aid flow from UN agencies (US$) of Lower middle income in 2009?
Provide a succinct answer. 9.05e+06. What is the difference between the Aid flow from UN agencies (US$) in Fragile and conflict affected situations in 2008 and the Aid flow from UN agencies (US$) in Middle income in 2009?
Provide a short and direct response. -1.76e+08. What is the difference between the Aid flow from UN agencies (US$) in Lower middle income in 2008 and the Aid flow from UN agencies (US$) in Middle income in 2009?
Your answer should be very brief. -1.76e+08. What is the difference between the Aid flow from UN agencies (US$) of Arab World in 2008 and the Aid flow from UN agencies (US$) of Fragile and conflict affected situations in 2010?
Make the answer very short. 1.32e+08. What is the difference between the Aid flow from UN agencies (US$) of Arab World in 2008 and the Aid flow from UN agencies (US$) of Lower middle income in 2010?
Make the answer very short. 1.32e+08. What is the difference between the Aid flow from UN agencies (US$) in Arab World in 2008 and the Aid flow from UN agencies (US$) in Middle income in 2010?
Your response must be concise. -7.18e+07. What is the difference between the Aid flow from UN agencies (US$) in Fragile and conflict affected situations in 2008 and the Aid flow from UN agencies (US$) in Lower middle income in 2010?
Make the answer very short. -4.42e+07. What is the difference between the Aid flow from UN agencies (US$) in Fragile and conflict affected situations in 2008 and the Aid flow from UN agencies (US$) in Middle income in 2010?
Your answer should be compact. -2.48e+08. What is the difference between the Aid flow from UN agencies (US$) of Lower middle income in 2008 and the Aid flow from UN agencies (US$) of Middle income in 2010?
Provide a succinct answer. -2.48e+08. What is the difference between the Aid flow from UN agencies (US$) of Arab World in 2008 and the Aid flow from UN agencies (US$) of Fragile and conflict affected situations in 2011?
Your response must be concise. 7.61e+07. What is the difference between the Aid flow from UN agencies (US$) in Arab World in 2008 and the Aid flow from UN agencies (US$) in Lower middle income in 2011?
Offer a very short reply. 7.61e+07. What is the difference between the Aid flow from UN agencies (US$) of Arab World in 2008 and the Aid flow from UN agencies (US$) of Middle income in 2011?
Your response must be concise. -1.35e+08. What is the difference between the Aid flow from UN agencies (US$) of Fragile and conflict affected situations in 2008 and the Aid flow from UN agencies (US$) of Lower middle income in 2011?
Give a very brief answer. -1.00e+08. What is the difference between the Aid flow from UN agencies (US$) of Fragile and conflict affected situations in 2008 and the Aid flow from UN agencies (US$) of Middle income in 2011?
Offer a very short reply. -3.11e+08. What is the difference between the Aid flow from UN agencies (US$) in Lower middle income in 2008 and the Aid flow from UN agencies (US$) in Middle income in 2011?
Make the answer very short. -3.11e+08. What is the difference between the Aid flow from UN agencies (US$) of Arab World in 2009 and the Aid flow from UN agencies (US$) of Fragile and conflict affected situations in 2010?
Make the answer very short. 1.32e+08. What is the difference between the Aid flow from UN agencies (US$) in Arab World in 2009 and the Aid flow from UN agencies (US$) in Lower middle income in 2010?
Give a very brief answer. 1.32e+08. What is the difference between the Aid flow from UN agencies (US$) of Arab World in 2009 and the Aid flow from UN agencies (US$) of Middle income in 2010?
Your response must be concise. -7.21e+07. What is the difference between the Aid flow from UN agencies (US$) in Fragile and conflict affected situations in 2009 and the Aid flow from UN agencies (US$) in Lower middle income in 2010?
Your response must be concise. -5.33e+07. What is the difference between the Aid flow from UN agencies (US$) of Fragile and conflict affected situations in 2009 and the Aid flow from UN agencies (US$) of Middle income in 2010?
Give a very brief answer. -2.57e+08. What is the difference between the Aid flow from UN agencies (US$) of Lower middle income in 2009 and the Aid flow from UN agencies (US$) of Middle income in 2010?
Make the answer very short. -2.57e+08. What is the difference between the Aid flow from UN agencies (US$) in Arab World in 2009 and the Aid flow from UN agencies (US$) in Fragile and conflict affected situations in 2011?
Make the answer very short. 7.57e+07. What is the difference between the Aid flow from UN agencies (US$) of Arab World in 2009 and the Aid flow from UN agencies (US$) of Lower middle income in 2011?
Make the answer very short. 7.57e+07. What is the difference between the Aid flow from UN agencies (US$) of Arab World in 2009 and the Aid flow from UN agencies (US$) of Middle income in 2011?
Ensure brevity in your answer.  -1.35e+08. What is the difference between the Aid flow from UN agencies (US$) of Fragile and conflict affected situations in 2009 and the Aid flow from UN agencies (US$) of Lower middle income in 2011?
Make the answer very short. -1.09e+08. What is the difference between the Aid flow from UN agencies (US$) of Fragile and conflict affected situations in 2009 and the Aid flow from UN agencies (US$) of Middle income in 2011?
Provide a short and direct response. -3.20e+08. What is the difference between the Aid flow from UN agencies (US$) of Lower middle income in 2009 and the Aid flow from UN agencies (US$) of Middle income in 2011?
Keep it short and to the point. -3.20e+08. What is the difference between the Aid flow from UN agencies (US$) in Arab World in 2010 and the Aid flow from UN agencies (US$) in Fragile and conflict affected situations in 2011?
Your answer should be compact. 1.48e+08. What is the difference between the Aid flow from UN agencies (US$) in Arab World in 2010 and the Aid flow from UN agencies (US$) in Lower middle income in 2011?
Your answer should be very brief. 1.48e+08. What is the difference between the Aid flow from UN agencies (US$) of Arab World in 2010 and the Aid flow from UN agencies (US$) of Middle income in 2011?
Your answer should be very brief. -6.30e+07. What is the difference between the Aid flow from UN agencies (US$) in Fragile and conflict affected situations in 2010 and the Aid flow from UN agencies (US$) in Lower middle income in 2011?
Your response must be concise. -5.60e+07. What is the difference between the Aid flow from UN agencies (US$) in Fragile and conflict affected situations in 2010 and the Aid flow from UN agencies (US$) in Middle income in 2011?
Ensure brevity in your answer.  -2.67e+08. What is the difference between the Aid flow from UN agencies (US$) in Lower middle income in 2010 and the Aid flow from UN agencies (US$) in Middle income in 2011?
Provide a succinct answer. -2.67e+08. What is the average Aid flow from UN agencies (US$) in Arab World per year?
Keep it short and to the point. 4.57e+08. What is the average Aid flow from UN agencies (US$) of Fragile and conflict affected situations per year?
Ensure brevity in your answer.  2.87e+08. What is the average Aid flow from UN agencies (US$) in Lower middle income per year?
Give a very brief answer. 2.87e+08. What is the average Aid flow from UN agencies (US$) of Middle income per year?
Your answer should be compact. 4.57e+08. In the year 2004, what is the difference between the Aid flow from UN agencies (US$) of Arab World and Aid flow from UN agencies (US$) of Fragile and conflict affected situations?
Ensure brevity in your answer.  1.47e+08. In the year 2004, what is the difference between the Aid flow from UN agencies (US$) in Arab World and Aid flow from UN agencies (US$) in Lower middle income?
Provide a succinct answer. 1.47e+08. In the year 2004, what is the difference between the Aid flow from UN agencies (US$) of Fragile and conflict affected situations and Aid flow from UN agencies (US$) of Lower middle income?
Keep it short and to the point. 0. In the year 2004, what is the difference between the Aid flow from UN agencies (US$) of Fragile and conflict affected situations and Aid flow from UN agencies (US$) of Middle income?
Keep it short and to the point. -1.47e+08. In the year 2004, what is the difference between the Aid flow from UN agencies (US$) of Lower middle income and Aid flow from UN agencies (US$) of Middle income?
Provide a short and direct response. -1.47e+08. In the year 2005, what is the difference between the Aid flow from UN agencies (US$) of Arab World and Aid flow from UN agencies (US$) of Fragile and conflict affected situations?
Offer a terse response. 1.44e+08. In the year 2005, what is the difference between the Aid flow from UN agencies (US$) in Arab World and Aid flow from UN agencies (US$) in Lower middle income?
Ensure brevity in your answer.  1.44e+08. In the year 2005, what is the difference between the Aid flow from UN agencies (US$) of Fragile and conflict affected situations and Aid flow from UN agencies (US$) of Middle income?
Offer a very short reply. -1.44e+08. In the year 2005, what is the difference between the Aid flow from UN agencies (US$) of Lower middle income and Aid flow from UN agencies (US$) of Middle income?
Ensure brevity in your answer.  -1.44e+08. In the year 2006, what is the difference between the Aid flow from UN agencies (US$) in Arab World and Aid flow from UN agencies (US$) in Fragile and conflict affected situations?
Provide a short and direct response. 1.43e+08. In the year 2006, what is the difference between the Aid flow from UN agencies (US$) of Arab World and Aid flow from UN agencies (US$) of Lower middle income?
Your response must be concise. 1.43e+08. In the year 2006, what is the difference between the Aid flow from UN agencies (US$) in Arab World and Aid flow from UN agencies (US$) in Middle income?
Your answer should be very brief. 0. In the year 2006, what is the difference between the Aid flow from UN agencies (US$) of Fragile and conflict affected situations and Aid flow from UN agencies (US$) of Lower middle income?
Provide a succinct answer. 0. In the year 2006, what is the difference between the Aid flow from UN agencies (US$) of Fragile and conflict affected situations and Aid flow from UN agencies (US$) of Middle income?
Make the answer very short. -1.43e+08. In the year 2006, what is the difference between the Aid flow from UN agencies (US$) of Lower middle income and Aid flow from UN agencies (US$) of Middle income?
Offer a terse response. -1.43e+08. In the year 2007, what is the difference between the Aid flow from UN agencies (US$) in Arab World and Aid flow from UN agencies (US$) in Fragile and conflict affected situations?
Ensure brevity in your answer.  1.51e+08. In the year 2007, what is the difference between the Aid flow from UN agencies (US$) in Arab World and Aid flow from UN agencies (US$) in Lower middle income?
Provide a succinct answer. 1.51e+08. In the year 2007, what is the difference between the Aid flow from UN agencies (US$) in Fragile and conflict affected situations and Aid flow from UN agencies (US$) in Middle income?
Give a very brief answer. -1.51e+08. In the year 2007, what is the difference between the Aid flow from UN agencies (US$) of Lower middle income and Aid flow from UN agencies (US$) of Middle income?
Keep it short and to the point. -1.51e+08. In the year 2008, what is the difference between the Aid flow from UN agencies (US$) of Arab World and Aid flow from UN agencies (US$) of Fragile and conflict affected situations?
Your answer should be compact. 1.76e+08. In the year 2008, what is the difference between the Aid flow from UN agencies (US$) of Arab World and Aid flow from UN agencies (US$) of Lower middle income?
Ensure brevity in your answer.  1.76e+08. In the year 2008, what is the difference between the Aid flow from UN agencies (US$) of Fragile and conflict affected situations and Aid flow from UN agencies (US$) of Lower middle income?
Your answer should be very brief. 0. In the year 2008, what is the difference between the Aid flow from UN agencies (US$) of Fragile and conflict affected situations and Aid flow from UN agencies (US$) of Middle income?
Your answer should be compact. -1.76e+08. In the year 2008, what is the difference between the Aid flow from UN agencies (US$) in Lower middle income and Aid flow from UN agencies (US$) in Middle income?
Offer a very short reply. -1.76e+08. In the year 2009, what is the difference between the Aid flow from UN agencies (US$) in Arab World and Aid flow from UN agencies (US$) in Fragile and conflict affected situations?
Make the answer very short. 1.85e+08. In the year 2009, what is the difference between the Aid flow from UN agencies (US$) of Arab World and Aid flow from UN agencies (US$) of Lower middle income?
Keep it short and to the point. 1.85e+08. In the year 2009, what is the difference between the Aid flow from UN agencies (US$) in Arab World and Aid flow from UN agencies (US$) in Middle income?
Ensure brevity in your answer.  0. In the year 2009, what is the difference between the Aid flow from UN agencies (US$) of Fragile and conflict affected situations and Aid flow from UN agencies (US$) of Lower middle income?
Offer a very short reply. 0. In the year 2009, what is the difference between the Aid flow from UN agencies (US$) in Fragile and conflict affected situations and Aid flow from UN agencies (US$) in Middle income?
Provide a succinct answer. -1.85e+08. In the year 2009, what is the difference between the Aid flow from UN agencies (US$) of Lower middle income and Aid flow from UN agencies (US$) of Middle income?
Your answer should be compact. -1.85e+08. In the year 2010, what is the difference between the Aid flow from UN agencies (US$) in Arab World and Aid flow from UN agencies (US$) in Fragile and conflict affected situations?
Provide a short and direct response. 2.04e+08. In the year 2010, what is the difference between the Aid flow from UN agencies (US$) in Arab World and Aid flow from UN agencies (US$) in Lower middle income?
Offer a terse response. 2.04e+08. In the year 2010, what is the difference between the Aid flow from UN agencies (US$) of Fragile and conflict affected situations and Aid flow from UN agencies (US$) of Middle income?
Keep it short and to the point. -2.04e+08. In the year 2010, what is the difference between the Aid flow from UN agencies (US$) in Lower middle income and Aid flow from UN agencies (US$) in Middle income?
Provide a short and direct response. -2.04e+08. In the year 2011, what is the difference between the Aid flow from UN agencies (US$) in Arab World and Aid flow from UN agencies (US$) in Fragile and conflict affected situations?
Your response must be concise. 2.11e+08. In the year 2011, what is the difference between the Aid flow from UN agencies (US$) of Arab World and Aid flow from UN agencies (US$) of Lower middle income?
Offer a very short reply. 2.11e+08. In the year 2011, what is the difference between the Aid flow from UN agencies (US$) of Fragile and conflict affected situations and Aid flow from UN agencies (US$) of Lower middle income?
Keep it short and to the point. 0. In the year 2011, what is the difference between the Aid flow from UN agencies (US$) in Fragile and conflict affected situations and Aid flow from UN agencies (US$) in Middle income?
Provide a succinct answer. -2.11e+08. In the year 2011, what is the difference between the Aid flow from UN agencies (US$) of Lower middle income and Aid flow from UN agencies (US$) of Middle income?
Ensure brevity in your answer.  -2.11e+08. What is the ratio of the Aid flow from UN agencies (US$) in Arab World in 2004 to that in 2005?
Make the answer very short. 1.28. What is the ratio of the Aid flow from UN agencies (US$) in Fragile and conflict affected situations in 2004 to that in 2005?
Provide a succinct answer. 1.46. What is the ratio of the Aid flow from UN agencies (US$) of Lower middle income in 2004 to that in 2005?
Your answer should be very brief. 1.46. What is the ratio of the Aid flow from UN agencies (US$) of Middle income in 2004 to that in 2005?
Offer a terse response. 1.28. What is the ratio of the Aid flow from UN agencies (US$) in Arab World in 2004 to that in 2006?
Make the answer very short. 1.21. What is the ratio of the Aid flow from UN agencies (US$) in Fragile and conflict affected situations in 2004 to that in 2006?
Your answer should be very brief. 1.32. What is the ratio of the Aid flow from UN agencies (US$) in Lower middle income in 2004 to that in 2006?
Ensure brevity in your answer.  1.32. What is the ratio of the Aid flow from UN agencies (US$) in Middle income in 2004 to that in 2006?
Your response must be concise. 1.21. What is the ratio of the Aid flow from UN agencies (US$) in Arab World in 2004 to that in 2007?
Keep it short and to the point. 1.16. What is the ratio of the Aid flow from UN agencies (US$) in Fragile and conflict affected situations in 2004 to that in 2007?
Your response must be concise. 1.27. What is the ratio of the Aid flow from UN agencies (US$) of Lower middle income in 2004 to that in 2007?
Keep it short and to the point. 1.27. What is the ratio of the Aid flow from UN agencies (US$) in Middle income in 2004 to that in 2007?
Provide a short and direct response. 1.16. What is the ratio of the Aid flow from UN agencies (US$) in Arab World in 2004 to that in 2008?
Offer a terse response. 0.95. What is the ratio of the Aid flow from UN agencies (US$) of Fragile and conflict affected situations in 2004 to that in 2008?
Your response must be concise. 1.02. What is the ratio of the Aid flow from UN agencies (US$) of Lower middle income in 2004 to that in 2008?
Provide a short and direct response. 1.02. What is the ratio of the Aid flow from UN agencies (US$) of Middle income in 2004 to that in 2008?
Provide a succinct answer. 0.95. What is the ratio of the Aid flow from UN agencies (US$) of Arab World in 2004 to that in 2009?
Ensure brevity in your answer.  0.95. What is the ratio of the Aid flow from UN agencies (US$) of Fragile and conflict affected situations in 2004 to that in 2009?
Make the answer very short. 1.05. What is the ratio of the Aid flow from UN agencies (US$) of Lower middle income in 2004 to that in 2009?
Ensure brevity in your answer.  1.05. What is the ratio of the Aid flow from UN agencies (US$) of Middle income in 2004 to that in 2009?
Your answer should be compact. 0.95. What is the ratio of the Aid flow from UN agencies (US$) in Arab World in 2004 to that in 2010?
Ensure brevity in your answer.  0.82. What is the ratio of the Aid flow from UN agencies (US$) in Fragile and conflict affected situations in 2004 to that in 2010?
Your response must be concise. 0.88. What is the ratio of the Aid flow from UN agencies (US$) in Lower middle income in 2004 to that in 2010?
Offer a terse response. 0.88. What is the ratio of the Aid flow from UN agencies (US$) of Middle income in 2004 to that in 2010?
Give a very brief answer. 0.82. What is the ratio of the Aid flow from UN agencies (US$) of Arab World in 2004 to that in 2011?
Keep it short and to the point. 0.74. What is the ratio of the Aid flow from UN agencies (US$) of Fragile and conflict affected situations in 2004 to that in 2011?
Give a very brief answer. 0.76. What is the ratio of the Aid flow from UN agencies (US$) of Lower middle income in 2004 to that in 2011?
Your answer should be compact. 0.76. What is the ratio of the Aid flow from UN agencies (US$) in Middle income in 2004 to that in 2011?
Ensure brevity in your answer.  0.74. What is the ratio of the Aid flow from UN agencies (US$) in Arab World in 2005 to that in 2006?
Your answer should be compact. 0.94. What is the ratio of the Aid flow from UN agencies (US$) of Fragile and conflict affected situations in 2005 to that in 2006?
Your response must be concise. 0.9. What is the ratio of the Aid flow from UN agencies (US$) in Lower middle income in 2005 to that in 2006?
Your answer should be compact. 0.9. What is the ratio of the Aid flow from UN agencies (US$) of Middle income in 2005 to that in 2006?
Offer a terse response. 0.94. What is the ratio of the Aid flow from UN agencies (US$) of Arab World in 2005 to that in 2007?
Your answer should be compact. 0.9. What is the ratio of the Aid flow from UN agencies (US$) of Fragile and conflict affected situations in 2005 to that in 2007?
Offer a terse response. 0.87. What is the ratio of the Aid flow from UN agencies (US$) in Lower middle income in 2005 to that in 2007?
Give a very brief answer. 0.87. What is the ratio of the Aid flow from UN agencies (US$) in Middle income in 2005 to that in 2007?
Your response must be concise. 0.9. What is the ratio of the Aid flow from UN agencies (US$) in Arab World in 2005 to that in 2008?
Keep it short and to the point. 0.74. What is the ratio of the Aid flow from UN agencies (US$) of Fragile and conflict affected situations in 2005 to that in 2008?
Provide a short and direct response. 0.7. What is the ratio of the Aid flow from UN agencies (US$) of Lower middle income in 2005 to that in 2008?
Your response must be concise. 0.7. What is the ratio of the Aid flow from UN agencies (US$) of Middle income in 2005 to that in 2008?
Offer a terse response. 0.74. What is the ratio of the Aid flow from UN agencies (US$) in Arab World in 2005 to that in 2009?
Offer a terse response. 0.74. What is the ratio of the Aid flow from UN agencies (US$) in Fragile and conflict affected situations in 2005 to that in 2009?
Make the answer very short. 0.72. What is the ratio of the Aid flow from UN agencies (US$) in Lower middle income in 2005 to that in 2009?
Give a very brief answer. 0.72. What is the ratio of the Aid flow from UN agencies (US$) of Middle income in 2005 to that in 2009?
Provide a succinct answer. 0.74. What is the ratio of the Aid flow from UN agencies (US$) of Arab World in 2005 to that in 2010?
Keep it short and to the point. 0.64. What is the ratio of the Aid flow from UN agencies (US$) in Fragile and conflict affected situations in 2005 to that in 2010?
Your response must be concise. 0.61. What is the ratio of the Aid flow from UN agencies (US$) in Lower middle income in 2005 to that in 2010?
Ensure brevity in your answer.  0.61. What is the ratio of the Aid flow from UN agencies (US$) in Middle income in 2005 to that in 2010?
Give a very brief answer. 0.64. What is the ratio of the Aid flow from UN agencies (US$) in Arab World in 2005 to that in 2011?
Provide a short and direct response. 0.58. What is the ratio of the Aid flow from UN agencies (US$) in Fragile and conflict affected situations in 2005 to that in 2011?
Your answer should be very brief. 0.52. What is the ratio of the Aid flow from UN agencies (US$) of Lower middle income in 2005 to that in 2011?
Your answer should be very brief. 0.52. What is the ratio of the Aid flow from UN agencies (US$) in Middle income in 2005 to that in 2011?
Your answer should be very brief. 0.58. What is the ratio of the Aid flow from UN agencies (US$) in Arab World in 2006 to that in 2007?
Offer a terse response. 0.96. What is the ratio of the Aid flow from UN agencies (US$) in Fragile and conflict affected situations in 2006 to that in 2007?
Your answer should be very brief. 0.96. What is the ratio of the Aid flow from UN agencies (US$) in Lower middle income in 2006 to that in 2007?
Provide a short and direct response. 0.96. What is the ratio of the Aid flow from UN agencies (US$) in Middle income in 2006 to that in 2007?
Offer a very short reply. 0.96. What is the ratio of the Aid flow from UN agencies (US$) of Arab World in 2006 to that in 2008?
Offer a very short reply. 0.79. What is the ratio of the Aid flow from UN agencies (US$) in Fragile and conflict affected situations in 2006 to that in 2008?
Give a very brief answer. 0.77. What is the ratio of the Aid flow from UN agencies (US$) of Lower middle income in 2006 to that in 2008?
Offer a terse response. 0.77. What is the ratio of the Aid flow from UN agencies (US$) in Middle income in 2006 to that in 2008?
Make the answer very short. 0.79. What is the ratio of the Aid flow from UN agencies (US$) of Arab World in 2006 to that in 2009?
Give a very brief answer. 0.79. What is the ratio of the Aid flow from UN agencies (US$) in Fragile and conflict affected situations in 2006 to that in 2009?
Offer a very short reply. 0.8. What is the ratio of the Aid flow from UN agencies (US$) in Lower middle income in 2006 to that in 2009?
Make the answer very short. 0.8. What is the ratio of the Aid flow from UN agencies (US$) in Middle income in 2006 to that in 2009?
Your answer should be very brief. 0.79. What is the ratio of the Aid flow from UN agencies (US$) in Arab World in 2006 to that in 2010?
Your answer should be compact. 0.68. What is the ratio of the Aid flow from UN agencies (US$) of Fragile and conflict affected situations in 2006 to that in 2010?
Provide a short and direct response. 0.67. What is the ratio of the Aid flow from UN agencies (US$) of Lower middle income in 2006 to that in 2010?
Your answer should be compact. 0.67. What is the ratio of the Aid flow from UN agencies (US$) in Middle income in 2006 to that in 2010?
Offer a terse response. 0.68. What is the ratio of the Aid flow from UN agencies (US$) of Arab World in 2006 to that in 2011?
Ensure brevity in your answer.  0.61. What is the ratio of the Aid flow from UN agencies (US$) of Fragile and conflict affected situations in 2006 to that in 2011?
Your answer should be very brief. 0.58. What is the ratio of the Aid flow from UN agencies (US$) of Lower middle income in 2006 to that in 2011?
Offer a very short reply. 0.58. What is the ratio of the Aid flow from UN agencies (US$) of Middle income in 2006 to that in 2011?
Offer a terse response. 0.61. What is the ratio of the Aid flow from UN agencies (US$) of Arab World in 2007 to that in 2008?
Offer a very short reply. 0.82. What is the ratio of the Aid flow from UN agencies (US$) in Fragile and conflict affected situations in 2007 to that in 2008?
Offer a terse response. 0.8. What is the ratio of the Aid flow from UN agencies (US$) in Lower middle income in 2007 to that in 2008?
Ensure brevity in your answer.  0.8. What is the ratio of the Aid flow from UN agencies (US$) in Middle income in 2007 to that in 2008?
Offer a very short reply. 0.82. What is the ratio of the Aid flow from UN agencies (US$) in Arab World in 2007 to that in 2009?
Offer a terse response. 0.82. What is the ratio of the Aid flow from UN agencies (US$) in Fragile and conflict affected situations in 2007 to that in 2009?
Give a very brief answer. 0.83. What is the ratio of the Aid flow from UN agencies (US$) of Lower middle income in 2007 to that in 2009?
Give a very brief answer. 0.83. What is the ratio of the Aid flow from UN agencies (US$) in Middle income in 2007 to that in 2009?
Your response must be concise. 0.82. What is the ratio of the Aid flow from UN agencies (US$) of Arab World in 2007 to that in 2010?
Ensure brevity in your answer.  0.71. What is the ratio of the Aid flow from UN agencies (US$) in Fragile and conflict affected situations in 2007 to that in 2010?
Offer a very short reply. 0.7. What is the ratio of the Aid flow from UN agencies (US$) in Lower middle income in 2007 to that in 2010?
Offer a very short reply. 0.7. What is the ratio of the Aid flow from UN agencies (US$) of Middle income in 2007 to that in 2010?
Provide a short and direct response. 0.71. What is the ratio of the Aid flow from UN agencies (US$) of Arab World in 2007 to that in 2011?
Give a very brief answer. 0.64. What is the ratio of the Aid flow from UN agencies (US$) in Fragile and conflict affected situations in 2007 to that in 2011?
Keep it short and to the point. 0.6. What is the ratio of the Aid flow from UN agencies (US$) of Lower middle income in 2007 to that in 2011?
Offer a very short reply. 0.6. What is the ratio of the Aid flow from UN agencies (US$) of Middle income in 2007 to that in 2011?
Your answer should be very brief. 0.64. What is the ratio of the Aid flow from UN agencies (US$) in Arab World in 2008 to that in 2009?
Your answer should be compact. 1. What is the ratio of the Aid flow from UN agencies (US$) of Fragile and conflict affected situations in 2008 to that in 2009?
Provide a succinct answer. 1.03. What is the ratio of the Aid flow from UN agencies (US$) of Lower middle income in 2008 to that in 2009?
Your response must be concise. 1.03. What is the ratio of the Aid flow from UN agencies (US$) of Arab World in 2008 to that in 2010?
Make the answer very short. 0.87. What is the ratio of the Aid flow from UN agencies (US$) in Fragile and conflict affected situations in 2008 to that in 2010?
Ensure brevity in your answer.  0.87. What is the ratio of the Aid flow from UN agencies (US$) of Lower middle income in 2008 to that in 2010?
Give a very brief answer. 0.87. What is the ratio of the Aid flow from UN agencies (US$) of Middle income in 2008 to that in 2010?
Your response must be concise. 0.87. What is the ratio of the Aid flow from UN agencies (US$) of Arab World in 2008 to that in 2011?
Make the answer very short. 0.78. What is the ratio of the Aid flow from UN agencies (US$) in Fragile and conflict affected situations in 2008 to that in 2011?
Give a very brief answer. 0.75. What is the ratio of the Aid flow from UN agencies (US$) of Lower middle income in 2008 to that in 2011?
Give a very brief answer. 0.75. What is the ratio of the Aid flow from UN agencies (US$) in Middle income in 2008 to that in 2011?
Offer a terse response. 0.78. What is the ratio of the Aid flow from UN agencies (US$) in Arab World in 2009 to that in 2010?
Make the answer very short. 0.87. What is the ratio of the Aid flow from UN agencies (US$) in Fragile and conflict affected situations in 2009 to that in 2010?
Your answer should be very brief. 0.84. What is the ratio of the Aid flow from UN agencies (US$) of Lower middle income in 2009 to that in 2010?
Provide a short and direct response. 0.84. What is the ratio of the Aid flow from UN agencies (US$) of Middle income in 2009 to that in 2010?
Your answer should be compact. 0.87. What is the ratio of the Aid flow from UN agencies (US$) of Arab World in 2009 to that in 2011?
Provide a succinct answer. 0.78. What is the ratio of the Aid flow from UN agencies (US$) in Fragile and conflict affected situations in 2009 to that in 2011?
Keep it short and to the point. 0.72. What is the ratio of the Aid flow from UN agencies (US$) in Lower middle income in 2009 to that in 2011?
Ensure brevity in your answer.  0.72. What is the ratio of the Aid flow from UN agencies (US$) of Arab World in 2010 to that in 2011?
Your answer should be very brief. 0.9. What is the ratio of the Aid flow from UN agencies (US$) of Fragile and conflict affected situations in 2010 to that in 2011?
Your response must be concise. 0.86. What is the ratio of the Aid flow from UN agencies (US$) of Lower middle income in 2010 to that in 2011?
Provide a short and direct response. 0.86. What is the ratio of the Aid flow from UN agencies (US$) in Middle income in 2010 to that in 2011?
Ensure brevity in your answer.  0.9. What is the difference between the highest and the second highest Aid flow from UN agencies (US$) in Arab World?
Make the answer very short. 6.30e+07. What is the difference between the highest and the second highest Aid flow from UN agencies (US$) of Fragile and conflict affected situations?
Offer a terse response. 5.60e+07. What is the difference between the highest and the second highest Aid flow from UN agencies (US$) of Lower middle income?
Give a very brief answer. 5.60e+07. What is the difference between the highest and the second highest Aid flow from UN agencies (US$) in Middle income?
Provide a succinct answer. 6.30e+07. What is the difference between the highest and the lowest Aid flow from UN agencies (US$) of Arab World?
Make the answer very short. 2.58e+08. What is the difference between the highest and the lowest Aid flow from UN agencies (US$) of Fragile and conflict affected situations?
Your answer should be compact. 1.91e+08. What is the difference between the highest and the lowest Aid flow from UN agencies (US$) of Lower middle income?
Make the answer very short. 1.91e+08. What is the difference between the highest and the lowest Aid flow from UN agencies (US$) in Middle income?
Keep it short and to the point. 2.58e+08. 